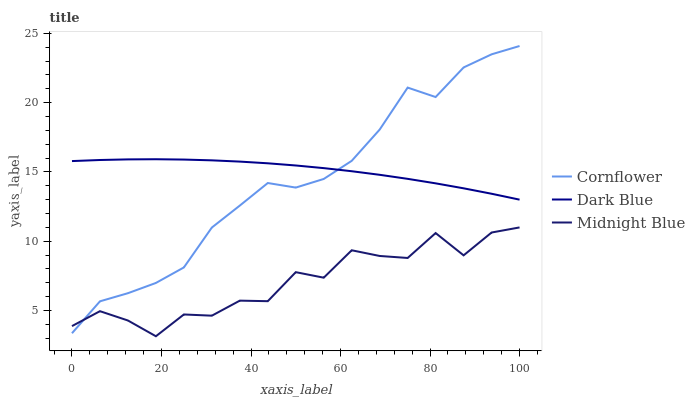Does Dark Blue have the minimum area under the curve?
Answer yes or no. No. Does Midnight Blue have the maximum area under the curve?
Answer yes or no. No. Is Midnight Blue the smoothest?
Answer yes or no. No. Is Dark Blue the roughest?
Answer yes or no. No. Does Dark Blue have the lowest value?
Answer yes or no. No. Does Dark Blue have the highest value?
Answer yes or no. No. Is Midnight Blue less than Dark Blue?
Answer yes or no. Yes. Is Dark Blue greater than Midnight Blue?
Answer yes or no. Yes. Does Midnight Blue intersect Dark Blue?
Answer yes or no. No. 